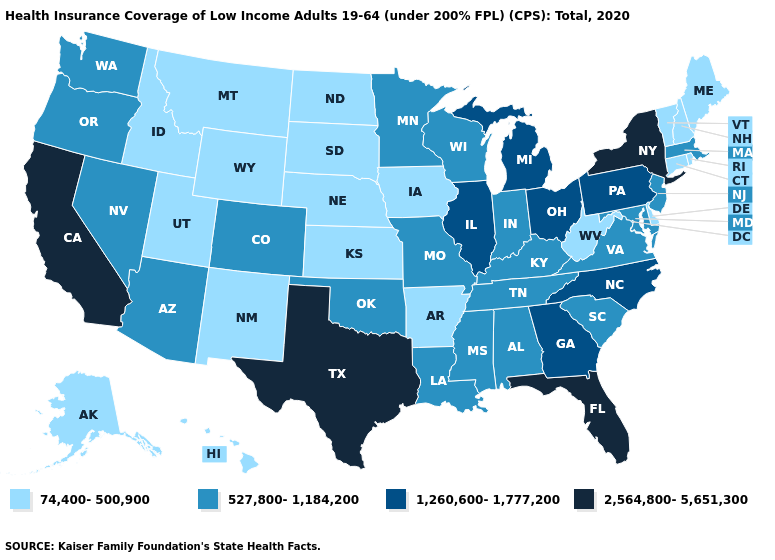Name the states that have a value in the range 2,564,800-5,651,300?
Quick response, please. California, Florida, New York, Texas. What is the value of Florida?
Be succinct. 2,564,800-5,651,300. Among the states that border North Carolina , which have the lowest value?
Concise answer only. South Carolina, Tennessee, Virginia. Name the states that have a value in the range 2,564,800-5,651,300?
Concise answer only. California, Florida, New York, Texas. How many symbols are there in the legend?
Concise answer only. 4. Among the states that border Texas , does New Mexico have the lowest value?
Be succinct. Yes. What is the value of Nevada?
Give a very brief answer. 527,800-1,184,200. Does Maryland have a lower value than Kansas?
Concise answer only. No. Among the states that border Missouri , which have the highest value?
Answer briefly. Illinois. What is the value of Louisiana?
Answer briefly. 527,800-1,184,200. What is the highest value in the USA?
Give a very brief answer. 2,564,800-5,651,300. Does Delaware have the lowest value in the South?
Write a very short answer. Yes. Does Michigan have the highest value in the MidWest?
Keep it brief. Yes. Is the legend a continuous bar?
Concise answer only. No. What is the highest value in the USA?
Short answer required. 2,564,800-5,651,300. 